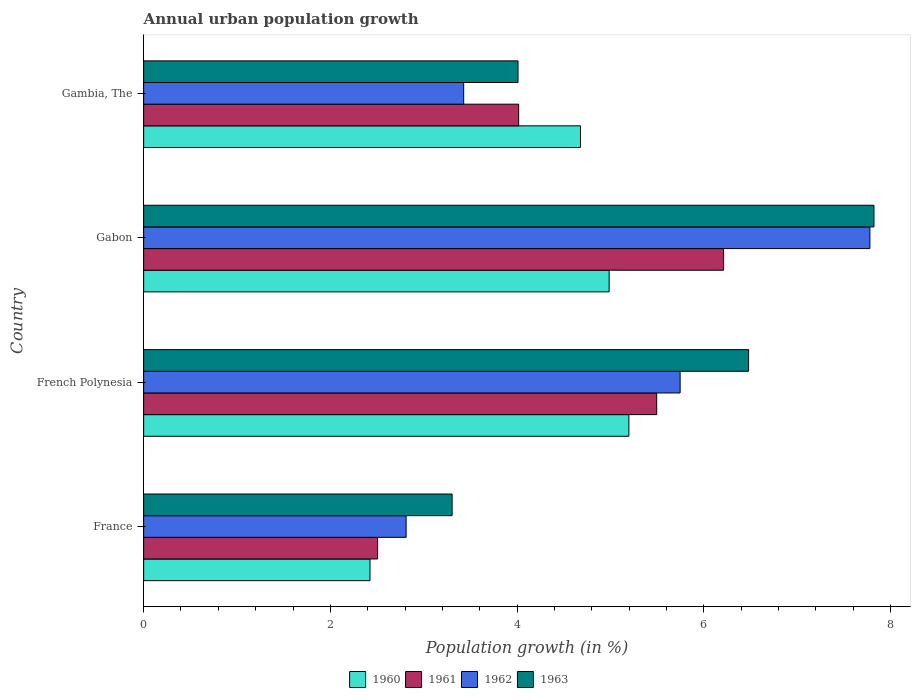How many different coloured bars are there?
Your answer should be compact. 4. Are the number of bars per tick equal to the number of legend labels?
Your answer should be compact. Yes. How many bars are there on the 3rd tick from the top?
Keep it short and to the point. 4. How many bars are there on the 4th tick from the bottom?
Your response must be concise. 4. What is the label of the 2nd group of bars from the top?
Offer a terse response. Gabon. What is the percentage of urban population growth in 1960 in Gabon?
Provide a short and direct response. 4.99. Across all countries, what is the maximum percentage of urban population growth in 1963?
Your response must be concise. 7.82. Across all countries, what is the minimum percentage of urban population growth in 1960?
Your answer should be very brief. 2.42. In which country was the percentage of urban population growth in 1960 maximum?
Keep it short and to the point. French Polynesia. In which country was the percentage of urban population growth in 1962 minimum?
Ensure brevity in your answer.  France. What is the total percentage of urban population growth in 1962 in the graph?
Ensure brevity in your answer.  19.76. What is the difference between the percentage of urban population growth in 1960 in France and that in French Polynesia?
Your answer should be compact. -2.77. What is the difference between the percentage of urban population growth in 1960 in French Polynesia and the percentage of urban population growth in 1961 in Gambia, The?
Your answer should be very brief. 1.18. What is the average percentage of urban population growth in 1962 per country?
Offer a terse response. 4.94. What is the difference between the percentage of urban population growth in 1962 and percentage of urban population growth in 1960 in France?
Make the answer very short. 0.39. What is the ratio of the percentage of urban population growth in 1961 in French Polynesia to that in Gambia, The?
Offer a very short reply. 1.37. Is the percentage of urban population growth in 1961 in French Polynesia less than that in Gabon?
Provide a succinct answer. Yes. Is the difference between the percentage of urban population growth in 1962 in France and Gambia, The greater than the difference between the percentage of urban population growth in 1960 in France and Gambia, The?
Your response must be concise. Yes. What is the difference between the highest and the second highest percentage of urban population growth in 1961?
Provide a short and direct response. 0.72. What is the difference between the highest and the lowest percentage of urban population growth in 1960?
Provide a succinct answer. 2.77. What does the 2nd bar from the top in French Polynesia represents?
Make the answer very short. 1962. What does the 4th bar from the bottom in Gabon represents?
Offer a terse response. 1963. Is it the case that in every country, the sum of the percentage of urban population growth in 1961 and percentage of urban population growth in 1963 is greater than the percentage of urban population growth in 1960?
Give a very brief answer. Yes. What is the difference between two consecutive major ticks on the X-axis?
Provide a short and direct response. 2. Are the values on the major ticks of X-axis written in scientific E-notation?
Your answer should be compact. No. Does the graph contain any zero values?
Provide a short and direct response. No. Does the graph contain grids?
Your response must be concise. No. Where does the legend appear in the graph?
Provide a short and direct response. Bottom center. How many legend labels are there?
Your answer should be very brief. 4. What is the title of the graph?
Provide a succinct answer. Annual urban population growth. Does "2007" appear as one of the legend labels in the graph?
Ensure brevity in your answer.  No. What is the label or title of the X-axis?
Your response must be concise. Population growth (in %). What is the Population growth (in %) of 1960 in France?
Make the answer very short. 2.42. What is the Population growth (in %) in 1961 in France?
Offer a very short reply. 2.51. What is the Population growth (in %) of 1962 in France?
Provide a short and direct response. 2.81. What is the Population growth (in %) in 1963 in France?
Offer a very short reply. 3.3. What is the Population growth (in %) in 1960 in French Polynesia?
Make the answer very short. 5.2. What is the Population growth (in %) of 1961 in French Polynesia?
Provide a short and direct response. 5.5. What is the Population growth (in %) of 1962 in French Polynesia?
Your answer should be compact. 5.75. What is the Population growth (in %) in 1963 in French Polynesia?
Offer a very short reply. 6.48. What is the Population growth (in %) of 1960 in Gabon?
Your response must be concise. 4.99. What is the Population growth (in %) in 1961 in Gabon?
Provide a short and direct response. 6.21. What is the Population growth (in %) of 1962 in Gabon?
Give a very brief answer. 7.78. What is the Population growth (in %) in 1963 in Gabon?
Your answer should be very brief. 7.82. What is the Population growth (in %) in 1960 in Gambia, The?
Keep it short and to the point. 4.68. What is the Population growth (in %) in 1961 in Gambia, The?
Provide a short and direct response. 4.02. What is the Population growth (in %) in 1962 in Gambia, The?
Your answer should be very brief. 3.43. What is the Population growth (in %) of 1963 in Gambia, The?
Your answer should be compact. 4.01. Across all countries, what is the maximum Population growth (in %) of 1960?
Offer a terse response. 5.2. Across all countries, what is the maximum Population growth (in %) of 1961?
Keep it short and to the point. 6.21. Across all countries, what is the maximum Population growth (in %) of 1962?
Your answer should be compact. 7.78. Across all countries, what is the maximum Population growth (in %) in 1963?
Give a very brief answer. 7.82. Across all countries, what is the minimum Population growth (in %) of 1960?
Your answer should be compact. 2.42. Across all countries, what is the minimum Population growth (in %) of 1961?
Offer a terse response. 2.51. Across all countries, what is the minimum Population growth (in %) in 1962?
Provide a short and direct response. 2.81. Across all countries, what is the minimum Population growth (in %) of 1963?
Ensure brevity in your answer.  3.3. What is the total Population growth (in %) in 1960 in the graph?
Give a very brief answer. 17.29. What is the total Population growth (in %) of 1961 in the graph?
Provide a succinct answer. 18.23. What is the total Population growth (in %) in 1962 in the graph?
Give a very brief answer. 19.76. What is the total Population growth (in %) of 1963 in the graph?
Offer a terse response. 21.62. What is the difference between the Population growth (in %) in 1960 in France and that in French Polynesia?
Offer a very short reply. -2.77. What is the difference between the Population growth (in %) in 1961 in France and that in French Polynesia?
Offer a very short reply. -2.99. What is the difference between the Population growth (in %) in 1962 in France and that in French Polynesia?
Provide a short and direct response. -2.94. What is the difference between the Population growth (in %) in 1963 in France and that in French Polynesia?
Provide a succinct answer. -3.18. What is the difference between the Population growth (in %) of 1960 in France and that in Gabon?
Your answer should be compact. -2.56. What is the difference between the Population growth (in %) in 1961 in France and that in Gabon?
Your answer should be compact. -3.71. What is the difference between the Population growth (in %) in 1962 in France and that in Gabon?
Keep it short and to the point. -4.97. What is the difference between the Population growth (in %) of 1963 in France and that in Gabon?
Keep it short and to the point. -4.52. What is the difference between the Population growth (in %) of 1960 in France and that in Gambia, The?
Provide a short and direct response. -2.25. What is the difference between the Population growth (in %) in 1961 in France and that in Gambia, The?
Offer a terse response. -1.51. What is the difference between the Population growth (in %) in 1962 in France and that in Gambia, The?
Provide a succinct answer. -0.62. What is the difference between the Population growth (in %) of 1963 in France and that in Gambia, The?
Your answer should be compact. -0.71. What is the difference between the Population growth (in %) in 1960 in French Polynesia and that in Gabon?
Keep it short and to the point. 0.21. What is the difference between the Population growth (in %) of 1961 in French Polynesia and that in Gabon?
Your response must be concise. -0.72. What is the difference between the Population growth (in %) in 1962 in French Polynesia and that in Gabon?
Provide a succinct answer. -2.03. What is the difference between the Population growth (in %) in 1963 in French Polynesia and that in Gabon?
Provide a succinct answer. -1.34. What is the difference between the Population growth (in %) of 1960 in French Polynesia and that in Gambia, The?
Ensure brevity in your answer.  0.52. What is the difference between the Population growth (in %) of 1961 in French Polynesia and that in Gambia, The?
Provide a short and direct response. 1.48. What is the difference between the Population growth (in %) of 1962 in French Polynesia and that in Gambia, The?
Your response must be concise. 2.32. What is the difference between the Population growth (in %) in 1963 in French Polynesia and that in Gambia, The?
Provide a short and direct response. 2.47. What is the difference between the Population growth (in %) of 1960 in Gabon and that in Gambia, The?
Offer a terse response. 0.31. What is the difference between the Population growth (in %) of 1961 in Gabon and that in Gambia, The?
Provide a succinct answer. 2.2. What is the difference between the Population growth (in %) in 1962 in Gabon and that in Gambia, The?
Give a very brief answer. 4.35. What is the difference between the Population growth (in %) in 1963 in Gabon and that in Gambia, The?
Give a very brief answer. 3.81. What is the difference between the Population growth (in %) in 1960 in France and the Population growth (in %) in 1961 in French Polynesia?
Offer a very short reply. -3.07. What is the difference between the Population growth (in %) in 1960 in France and the Population growth (in %) in 1962 in French Polynesia?
Ensure brevity in your answer.  -3.32. What is the difference between the Population growth (in %) in 1960 in France and the Population growth (in %) in 1963 in French Polynesia?
Your response must be concise. -4.06. What is the difference between the Population growth (in %) of 1961 in France and the Population growth (in %) of 1962 in French Polynesia?
Make the answer very short. -3.24. What is the difference between the Population growth (in %) of 1961 in France and the Population growth (in %) of 1963 in French Polynesia?
Provide a short and direct response. -3.97. What is the difference between the Population growth (in %) of 1962 in France and the Population growth (in %) of 1963 in French Polynesia?
Your response must be concise. -3.67. What is the difference between the Population growth (in %) of 1960 in France and the Population growth (in %) of 1961 in Gabon?
Your response must be concise. -3.79. What is the difference between the Population growth (in %) in 1960 in France and the Population growth (in %) in 1962 in Gabon?
Your answer should be compact. -5.35. What is the difference between the Population growth (in %) in 1960 in France and the Population growth (in %) in 1963 in Gabon?
Make the answer very short. -5.4. What is the difference between the Population growth (in %) in 1961 in France and the Population growth (in %) in 1962 in Gabon?
Keep it short and to the point. -5.27. What is the difference between the Population growth (in %) in 1961 in France and the Population growth (in %) in 1963 in Gabon?
Make the answer very short. -5.32. What is the difference between the Population growth (in %) in 1962 in France and the Population growth (in %) in 1963 in Gabon?
Offer a very short reply. -5.01. What is the difference between the Population growth (in %) of 1960 in France and the Population growth (in %) of 1961 in Gambia, The?
Provide a short and direct response. -1.59. What is the difference between the Population growth (in %) in 1960 in France and the Population growth (in %) in 1962 in Gambia, The?
Provide a succinct answer. -1. What is the difference between the Population growth (in %) of 1960 in France and the Population growth (in %) of 1963 in Gambia, The?
Make the answer very short. -1.59. What is the difference between the Population growth (in %) in 1961 in France and the Population growth (in %) in 1962 in Gambia, The?
Provide a short and direct response. -0.92. What is the difference between the Population growth (in %) in 1961 in France and the Population growth (in %) in 1963 in Gambia, The?
Your response must be concise. -1.5. What is the difference between the Population growth (in %) in 1962 in France and the Population growth (in %) in 1963 in Gambia, The?
Keep it short and to the point. -1.2. What is the difference between the Population growth (in %) in 1960 in French Polynesia and the Population growth (in %) in 1961 in Gabon?
Keep it short and to the point. -1.01. What is the difference between the Population growth (in %) of 1960 in French Polynesia and the Population growth (in %) of 1962 in Gabon?
Make the answer very short. -2.58. What is the difference between the Population growth (in %) in 1960 in French Polynesia and the Population growth (in %) in 1963 in Gabon?
Your answer should be very brief. -2.63. What is the difference between the Population growth (in %) in 1961 in French Polynesia and the Population growth (in %) in 1962 in Gabon?
Your answer should be very brief. -2.28. What is the difference between the Population growth (in %) in 1961 in French Polynesia and the Population growth (in %) in 1963 in Gabon?
Offer a terse response. -2.33. What is the difference between the Population growth (in %) in 1962 in French Polynesia and the Population growth (in %) in 1963 in Gabon?
Offer a terse response. -2.08. What is the difference between the Population growth (in %) of 1960 in French Polynesia and the Population growth (in %) of 1961 in Gambia, The?
Make the answer very short. 1.18. What is the difference between the Population growth (in %) of 1960 in French Polynesia and the Population growth (in %) of 1962 in Gambia, The?
Keep it short and to the point. 1.77. What is the difference between the Population growth (in %) of 1960 in French Polynesia and the Population growth (in %) of 1963 in Gambia, The?
Offer a terse response. 1.19. What is the difference between the Population growth (in %) in 1961 in French Polynesia and the Population growth (in %) in 1962 in Gambia, The?
Give a very brief answer. 2.07. What is the difference between the Population growth (in %) in 1961 in French Polynesia and the Population growth (in %) in 1963 in Gambia, The?
Offer a terse response. 1.49. What is the difference between the Population growth (in %) of 1962 in French Polynesia and the Population growth (in %) of 1963 in Gambia, The?
Your answer should be very brief. 1.74. What is the difference between the Population growth (in %) in 1960 in Gabon and the Population growth (in %) in 1961 in Gambia, The?
Your response must be concise. 0.97. What is the difference between the Population growth (in %) in 1960 in Gabon and the Population growth (in %) in 1962 in Gambia, The?
Provide a succinct answer. 1.56. What is the difference between the Population growth (in %) in 1960 in Gabon and the Population growth (in %) in 1963 in Gambia, The?
Your answer should be very brief. 0.98. What is the difference between the Population growth (in %) in 1961 in Gabon and the Population growth (in %) in 1962 in Gambia, The?
Keep it short and to the point. 2.78. What is the difference between the Population growth (in %) of 1961 in Gabon and the Population growth (in %) of 1963 in Gambia, The?
Provide a short and direct response. 2.2. What is the difference between the Population growth (in %) in 1962 in Gabon and the Population growth (in %) in 1963 in Gambia, The?
Your answer should be very brief. 3.77. What is the average Population growth (in %) in 1960 per country?
Give a very brief answer. 4.32. What is the average Population growth (in %) of 1961 per country?
Provide a succinct answer. 4.56. What is the average Population growth (in %) in 1962 per country?
Provide a short and direct response. 4.94. What is the average Population growth (in %) in 1963 per country?
Offer a terse response. 5.4. What is the difference between the Population growth (in %) of 1960 and Population growth (in %) of 1961 in France?
Give a very brief answer. -0.08. What is the difference between the Population growth (in %) in 1960 and Population growth (in %) in 1962 in France?
Keep it short and to the point. -0.39. What is the difference between the Population growth (in %) in 1960 and Population growth (in %) in 1963 in France?
Your response must be concise. -0.88. What is the difference between the Population growth (in %) in 1961 and Population growth (in %) in 1962 in France?
Offer a very short reply. -0.31. What is the difference between the Population growth (in %) in 1961 and Population growth (in %) in 1963 in France?
Keep it short and to the point. -0.8. What is the difference between the Population growth (in %) of 1962 and Population growth (in %) of 1963 in France?
Provide a succinct answer. -0.49. What is the difference between the Population growth (in %) of 1960 and Population growth (in %) of 1961 in French Polynesia?
Provide a short and direct response. -0.3. What is the difference between the Population growth (in %) in 1960 and Population growth (in %) in 1962 in French Polynesia?
Provide a short and direct response. -0.55. What is the difference between the Population growth (in %) in 1960 and Population growth (in %) in 1963 in French Polynesia?
Offer a terse response. -1.28. What is the difference between the Population growth (in %) of 1961 and Population growth (in %) of 1962 in French Polynesia?
Offer a terse response. -0.25. What is the difference between the Population growth (in %) in 1961 and Population growth (in %) in 1963 in French Polynesia?
Ensure brevity in your answer.  -0.98. What is the difference between the Population growth (in %) of 1962 and Population growth (in %) of 1963 in French Polynesia?
Provide a succinct answer. -0.73. What is the difference between the Population growth (in %) in 1960 and Population growth (in %) in 1961 in Gabon?
Provide a succinct answer. -1.23. What is the difference between the Population growth (in %) in 1960 and Population growth (in %) in 1962 in Gabon?
Your response must be concise. -2.79. What is the difference between the Population growth (in %) in 1960 and Population growth (in %) in 1963 in Gabon?
Provide a succinct answer. -2.84. What is the difference between the Population growth (in %) in 1961 and Population growth (in %) in 1962 in Gabon?
Your response must be concise. -1.57. What is the difference between the Population growth (in %) in 1961 and Population growth (in %) in 1963 in Gabon?
Offer a terse response. -1.61. What is the difference between the Population growth (in %) of 1962 and Population growth (in %) of 1963 in Gabon?
Make the answer very short. -0.04. What is the difference between the Population growth (in %) of 1960 and Population growth (in %) of 1961 in Gambia, The?
Offer a terse response. 0.66. What is the difference between the Population growth (in %) of 1960 and Population growth (in %) of 1962 in Gambia, The?
Keep it short and to the point. 1.25. What is the difference between the Population growth (in %) in 1960 and Population growth (in %) in 1963 in Gambia, The?
Keep it short and to the point. 0.67. What is the difference between the Population growth (in %) in 1961 and Population growth (in %) in 1962 in Gambia, The?
Give a very brief answer. 0.59. What is the difference between the Population growth (in %) in 1961 and Population growth (in %) in 1963 in Gambia, The?
Offer a very short reply. 0.01. What is the difference between the Population growth (in %) of 1962 and Population growth (in %) of 1963 in Gambia, The?
Provide a short and direct response. -0.58. What is the ratio of the Population growth (in %) in 1960 in France to that in French Polynesia?
Make the answer very short. 0.47. What is the ratio of the Population growth (in %) of 1961 in France to that in French Polynesia?
Give a very brief answer. 0.46. What is the ratio of the Population growth (in %) of 1962 in France to that in French Polynesia?
Provide a succinct answer. 0.49. What is the ratio of the Population growth (in %) of 1963 in France to that in French Polynesia?
Your answer should be very brief. 0.51. What is the ratio of the Population growth (in %) in 1960 in France to that in Gabon?
Provide a succinct answer. 0.49. What is the ratio of the Population growth (in %) in 1961 in France to that in Gabon?
Provide a short and direct response. 0.4. What is the ratio of the Population growth (in %) in 1962 in France to that in Gabon?
Give a very brief answer. 0.36. What is the ratio of the Population growth (in %) of 1963 in France to that in Gabon?
Your answer should be compact. 0.42. What is the ratio of the Population growth (in %) in 1960 in France to that in Gambia, The?
Ensure brevity in your answer.  0.52. What is the ratio of the Population growth (in %) of 1961 in France to that in Gambia, The?
Offer a terse response. 0.62. What is the ratio of the Population growth (in %) of 1962 in France to that in Gambia, The?
Keep it short and to the point. 0.82. What is the ratio of the Population growth (in %) in 1963 in France to that in Gambia, The?
Offer a terse response. 0.82. What is the ratio of the Population growth (in %) of 1960 in French Polynesia to that in Gabon?
Ensure brevity in your answer.  1.04. What is the ratio of the Population growth (in %) in 1961 in French Polynesia to that in Gabon?
Your answer should be compact. 0.88. What is the ratio of the Population growth (in %) of 1962 in French Polynesia to that in Gabon?
Keep it short and to the point. 0.74. What is the ratio of the Population growth (in %) of 1963 in French Polynesia to that in Gabon?
Keep it short and to the point. 0.83. What is the ratio of the Population growth (in %) of 1960 in French Polynesia to that in Gambia, The?
Give a very brief answer. 1.11. What is the ratio of the Population growth (in %) of 1961 in French Polynesia to that in Gambia, The?
Your answer should be compact. 1.37. What is the ratio of the Population growth (in %) of 1962 in French Polynesia to that in Gambia, The?
Provide a short and direct response. 1.68. What is the ratio of the Population growth (in %) of 1963 in French Polynesia to that in Gambia, The?
Make the answer very short. 1.62. What is the ratio of the Population growth (in %) in 1960 in Gabon to that in Gambia, The?
Provide a short and direct response. 1.07. What is the ratio of the Population growth (in %) of 1961 in Gabon to that in Gambia, The?
Make the answer very short. 1.55. What is the ratio of the Population growth (in %) in 1962 in Gabon to that in Gambia, The?
Your answer should be compact. 2.27. What is the ratio of the Population growth (in %) of 1963 in Gabon to that in Gambia, The?
Your response must be concise. 1.95. What is the difference between the highest and the second highest Population growth (in %) in 1960?
Make the answer very short. 0.21. What is the difference between the highest and the second highest Population growth (in %) in 1961?
Your answer should be compact. 0.72. What is the difference between the highest and the second highest Population growth (in %) in 1962?
Offer a terse response. 2.03. What is the difference between the highest and the second highest Population growth (in %) in 1963?
Your answer should be compact. 1.34. What is the difference between the highest and the lowest Population growth (in %) in 1960?
Your response must be concise. 2.77. What is the difference between the highest and the lowest Population growth (in %) in 1961?
Give a very brief answer. 3.71. What is the difference between the highest and the lowest Population growth (in %) of 1962?
Give a very brief answer. 4.97. What is the difference between the highest and the lowest Population growth (in %) in 1963?
Your answer should be very brief. 4.52. 